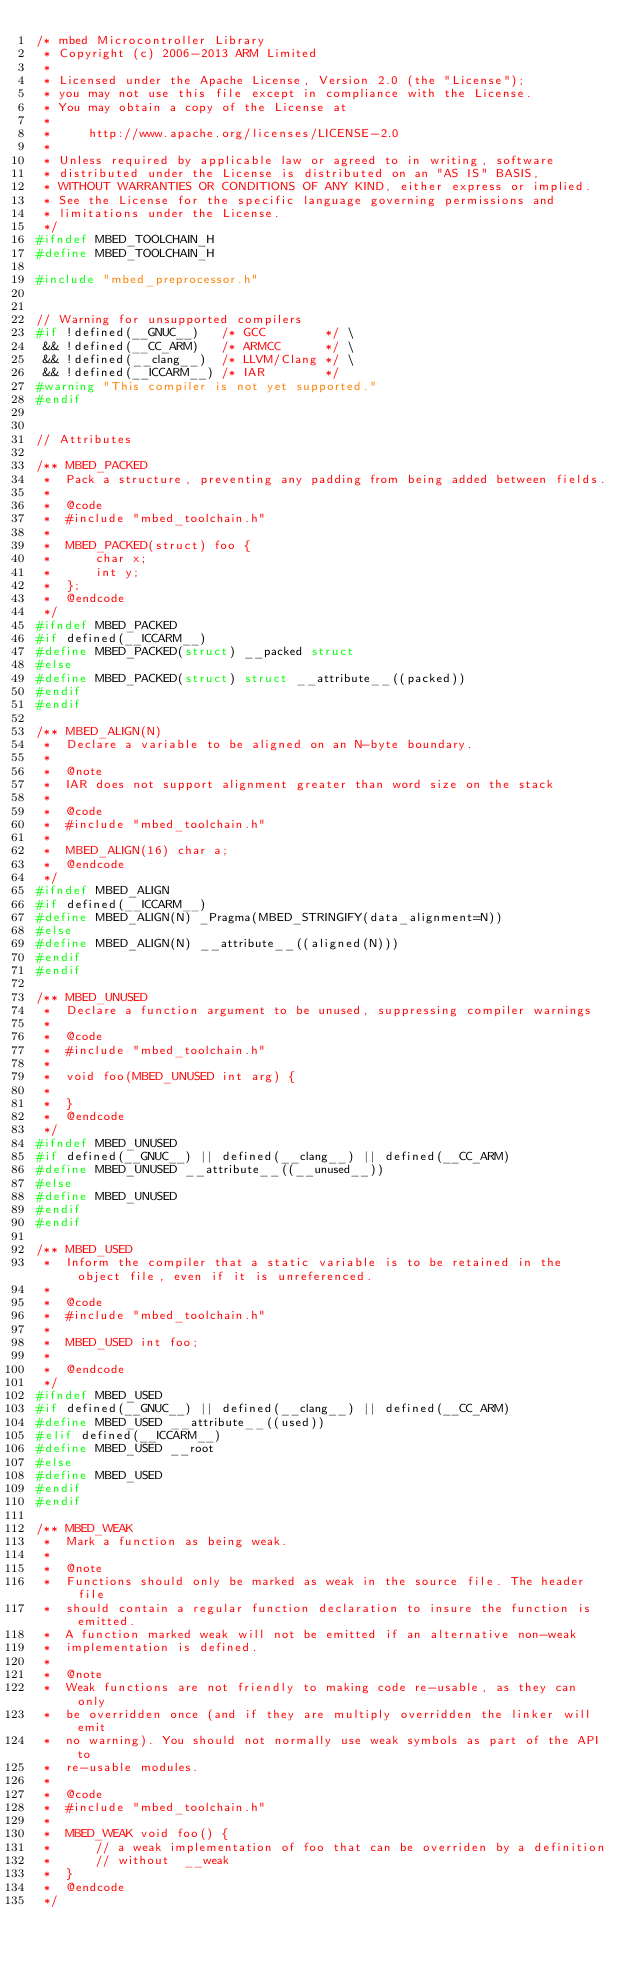<code> <loc_0><loc_0><loc_500><loc_500><_C_>/* mbed Microcontroller Library
 * Copyright (c) 2006-2013 ARM Limited
 *
 * Licensed under the Apache License, Version 2.0 (the "License");
 * you may not use this file except in compliance with the License.
 * You may obtain a copy of the License at
 *
 *     http://www.apache.org/licenses/LICENSE-2.0
 *
 * Unless required by applicable law or agreed to in writing, software
 * distributed under the License is distributed on an "AS IS" BASIS,
 * WITHOUT WARRANTIES OR CONDITIONS OF ANY KIND, either express or implied.
 * See the License for the specific language governing permissions and
 * limitations under the License.
 */
#ifndef MBED_TOOLCHAIN_H
#define MBED_TOOLCHAIN_H

#include "mbed_preprocessor.h"


// Warning for unsupported compilers
#if !defined(__GNUC__)   /* GCC        */ \
 && !defined(__CC_ARM)   /* ARMCC      */ \
 && !defined(__clang__)  /* LLVM/Clang */ \
 && !defined(__ICCARM__) /* IAR        */
#warning "This compiler is not yet supported."
#endif


// Attributes

/** MBED_PACKED
 *  Pack a structure, preventing any padding from being added between fields.
 *
 *  @code
 *  #include "mbed_toolchain.h"
 *
 *  MBED_PACKED(struct) foo {
 *      char x;
 *      int y;
 *  };
 *  @endcode
 */
#ifndef MBED_PACKED
#if defined(__ICCARM__)
#define MBED_PACKED(struct) __packed struct
#else
#define MBED_PACKED(struct) struct __attribute__((packed))
#endif
#endif

/** MBED_ALIGN(N)
 *  Declare a variable to be aligned on an N-byte boundary.
 *
 *  @note
 *  IAR does not support alignment greater than word size on the stack
 *
 *  @code
 *  #include "mbed_toolchain.h"
 *
 *  MBED_ALIGN(16) char a;
 *  @endcode
 */
#ifndef MBED_ALIGN
#if defined(__ICCARM__)
#define MBED_ALIGN(N) _Pragma(MBED_STRINGIFY(data_alignment=N))
#else
#define MBED_ALIGN(N) __attribute__((aligned(N)))
#endif
#endif

/** MBED_UNUSED
 *  Declare a function argument to be unused, suppressing compiler warnings
 *
 *  @code
 *  #include "mbed_toolchain.h"
 *
 *  void foo(MBED_UNUSED int arg) {
 *
 *  }
 *  @endcode
 */
#ifndef MBED_UNUSED
#if defined(__GNUC__) || defined(__clang__) || defined(__CC_ARM)
#define MBED_UNUSED __attribute__((__unused__))
#else
#define MBED_UNUSED
#endif
#endif

/** MBED_USED
 *  Inform the compiler that a static variable is to be retained in the object file, even if it is unreferenced.
 *
 *  @code
 *  #include "mbed_toolchain.h"
 *
 *  MBED_USED int foo;
 *
 *  @endcode
 */
#ifndef MBED_USED
#if defined(__GNUC__) || defined(__clang__) || defined(__CC_ARM)
#define MBED_USED __attribute__((used))
#elif defined(__ICCARM__)
#define MBED_USED __root
#else
#define MBED_USED
#endif
#endif

/** MBED_WEAK
 *  Mark a function as being weak.
 *
 *  @note
 *  Functions should only be marked as weak in the source file. The header file
 *  should contain a regular function declaration to insure the function is emitted.
 *  A function marked weak will not be emitted if an alternative non-weak
 *  implementation is defined.
 *
 *  @note
 *  Weak functions are not friendly to making code re-usable, as they can only
 *  be overridden once (and if they are multiply overridden the linker will emit
 *  no warning). You should not normally use weak symbols as part of the API to
 *  re-usable modules.
 *
 *  @code
 *  #include "mbed_toolchain.h"
 *
 *  MBED_WEAK void foo() {
 *      // a weak implementation of foo that can be overriden by a definition
 *      // without  __weak
 *  }
 *  @endcode
 */</code> 